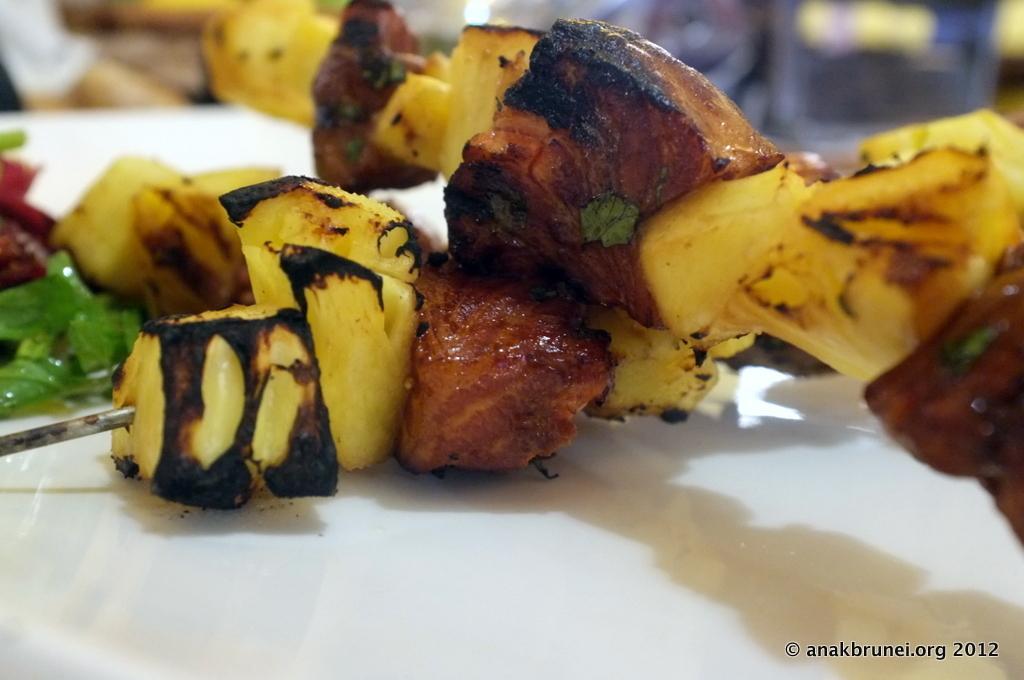Could you give a brief overview of what you see in this image? In the picture I can see food items on a white color surface. At the bottom right side of the image I can see a watermark. The background of the image is blurred. 